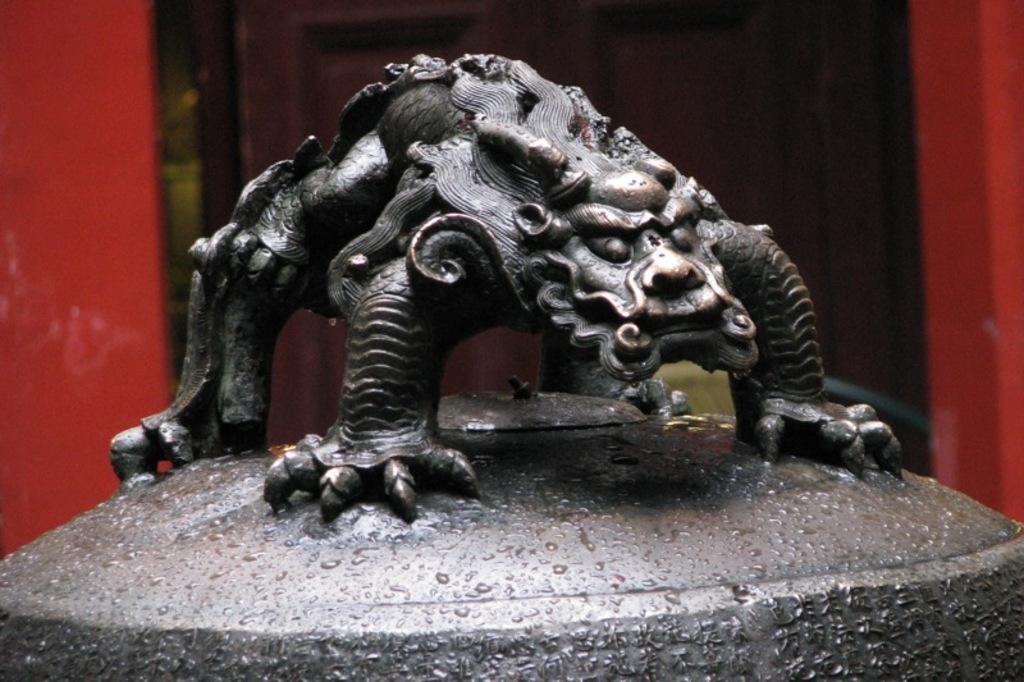Could you give a brief overview of what you see in this image? In the center of the picture there is an iron sculpture. In the background there is a door. 